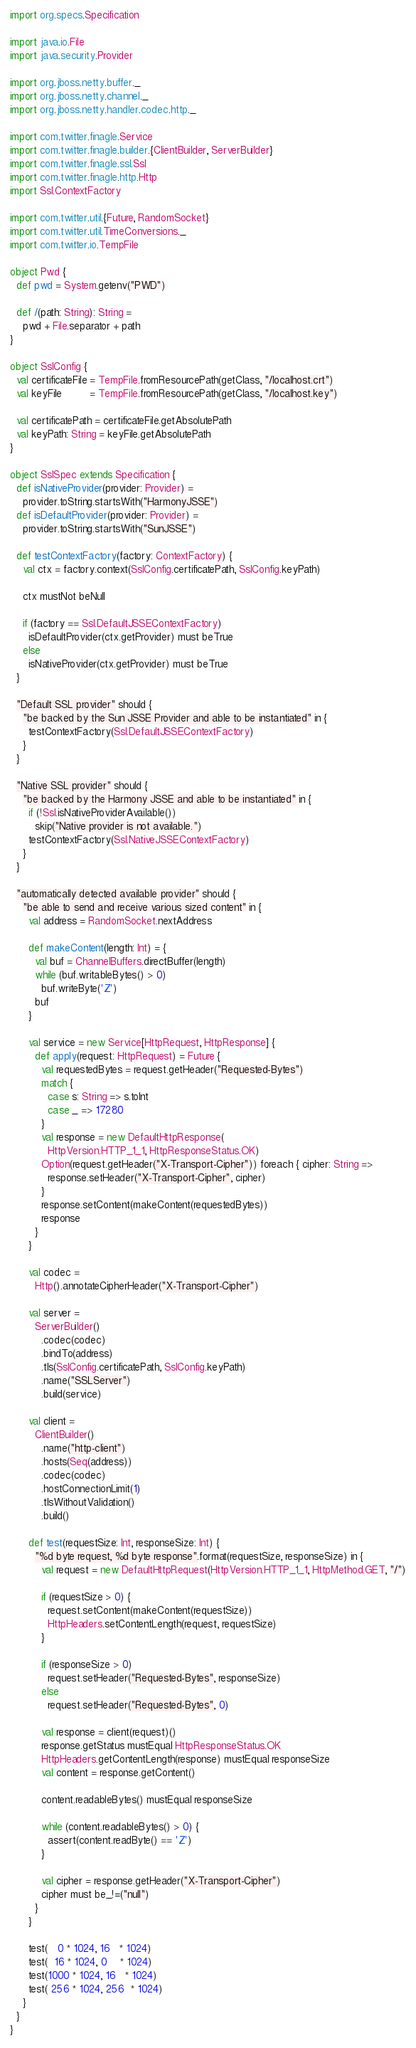<code> <loc_0><loc_0><loc_500><loc_500><_Scala_>import org.specs.Specification

import java.io.File
import java.security.Provider

import org.jboss.netty.buffer._
import org.jboss.netty.channel._
import org.jboss.netty.handler.codec.http._

import com.twitter.finagle.Service
import com.twitter.finagle.builder.{ClientBuilder, ServerBuilder}
import com.twitter.finagle.ssl.Ssl
import com.twitter.finagle.http.Http
import Ssl.ContextFactory

import com.twitter.util.{Future, RandomSocket}
import com.twitter.util.TimeConversions._
import com.twitter.io.TempFile

object Pwd {
  def pwd = System.getenv("PWD")

  def /(path: String): String =
    pwd + File.separator + path
}

object SslConfig {
  val certificateFile = TempFile.fromResourcePath(getClass, "/localhost.crt")
  val keyFile         = TempFile.fromResourcePath(getClass, "/localhost.key")

  val certificatePath = certificateFile.getAbsolutePath
  val keyPath: String = keyFile.getAbsolutePath
}

object SslSpec extends Specification {
  def isNativeProvider(provider: Provider) =
    provider.toString.startsWith("HarmonyJSSE")
  def isDefaultProvider(provider: Provider) =
    provider.toString.startsWith("SunJSSE")

  def testContextFactory(factory: ContextFactory) {
    val ctx = factory.context(SslConfig.certificatePath, SslConfig.keyPath)

    ctx mustNot beNull

    if (factory == Ssl.DefaultJSSEContextFactory)
      isDefaultProvider(ctx.getProvider) must beTrue
    else
      isNativeProvider(ctx.getProvider) must beTrue
  }

  "Default SSL provider" should {
    "be backed by the Sun JSSE Provider and able to be instantiated" in {
      testContextFactory(Ssl.DefaultJSSEContextFactory)
    }
  }

  "Native SSL provider" should {
    "be backed by the Harmony JSSE and able to be instantiated" in {
      if (!Ssl.isNativeProviderAvailable())
        skip("Native provider is not available.")
      testContextFactory(Ssl.NativeJSSEContextFactory)
    }
  }

  "automatically detected available provider" should {
    "be able to send and receive various sized content" in {
      val address = RandomSocket.nextAddress

      def makeContent(length: Int) = {
        val buf = ChannelBuffers.directBuffer(length)
        while (buf.writableBytes() > 0)
          buf.writeByte('Z')
        buf
      }

      val service = new Service[HttpRequest, HttpResponse] {
        def apply(request: HttpRequest) = Future {
          val requestedBytes = request.getHeader("Requested-Bytes")
          match {
            case s: String => s.toInt
            case _ => 17280
          }
          val response = new DefaultHttpResponse(
            HttpVersion.HTTP_1_1, HttpResponseStatus.OK)
          Option(request.getHeader("X-Transport-Cipher")) foreach { cipher: String =>
            response.setHeader("X-Transport-Cipher", cipher)
          }
          response.setContent(makeContent(requestedBytes))
          response
        }
      }

      val codec =
        Http().annotateCipherHeader("X-Transport-Cipher")

      val server =
        ServerBuilder()
          .codec(codec)
          .bindTo(address)
          .tls(SslConfig.certificatePath, SslConfig.keyPath)
          .name("SSLServer")
          .build(service)

      val client =
        ClientBuilder()
          .name("http-client")
          .hosts(Seq(address))
          .codec(codec)
          .hostConnectionLimit(1)
          .tlsWithoutValidation()
          .build()

      def test(requestSize: Int, responseSize: Int) {
        "%d byte request, %d byte response".format(requestSize, responseSize) in {
          val request = new DefaultHttpRequest(HttpVersion.HTTP_1_1, HttpMethod.GET, "/")

          if (requestSize > 0) {
            request.setContent(makeContent(requestSize))
            HttpHeaders.setContentLength(request, requestSize)
          }

          if (responseSize > 0)
            request.setHeader("Requested-Bytes", responseSize)
          else
            request.setHeader("Requested-Bytes", 0)

          val response = client(request)()
          response.getStatus mustEqual HttpResponseStatus.OK
          HttpHeaders.getContentLength(response) mustEqual responseSize
          val content = response.getContent()

          content.readableBytes() mustEqual responseSize

          while (content.readableBytes() > 0) {
            assert(content.readByte() == 'Z')
          }

          val cipher = response.getHeader("X-Transport-Cipher")
          cipher must be_!=("null")
        }
      }

      test(   0 * 1024, 16   * 1024)
      test(  16 * 1024, 0    * 1024)
      test(1000 * 1024, 16   * 1024)
      test( 256 * 1024, 256  * 1024)
    }
  }
}
</code> 